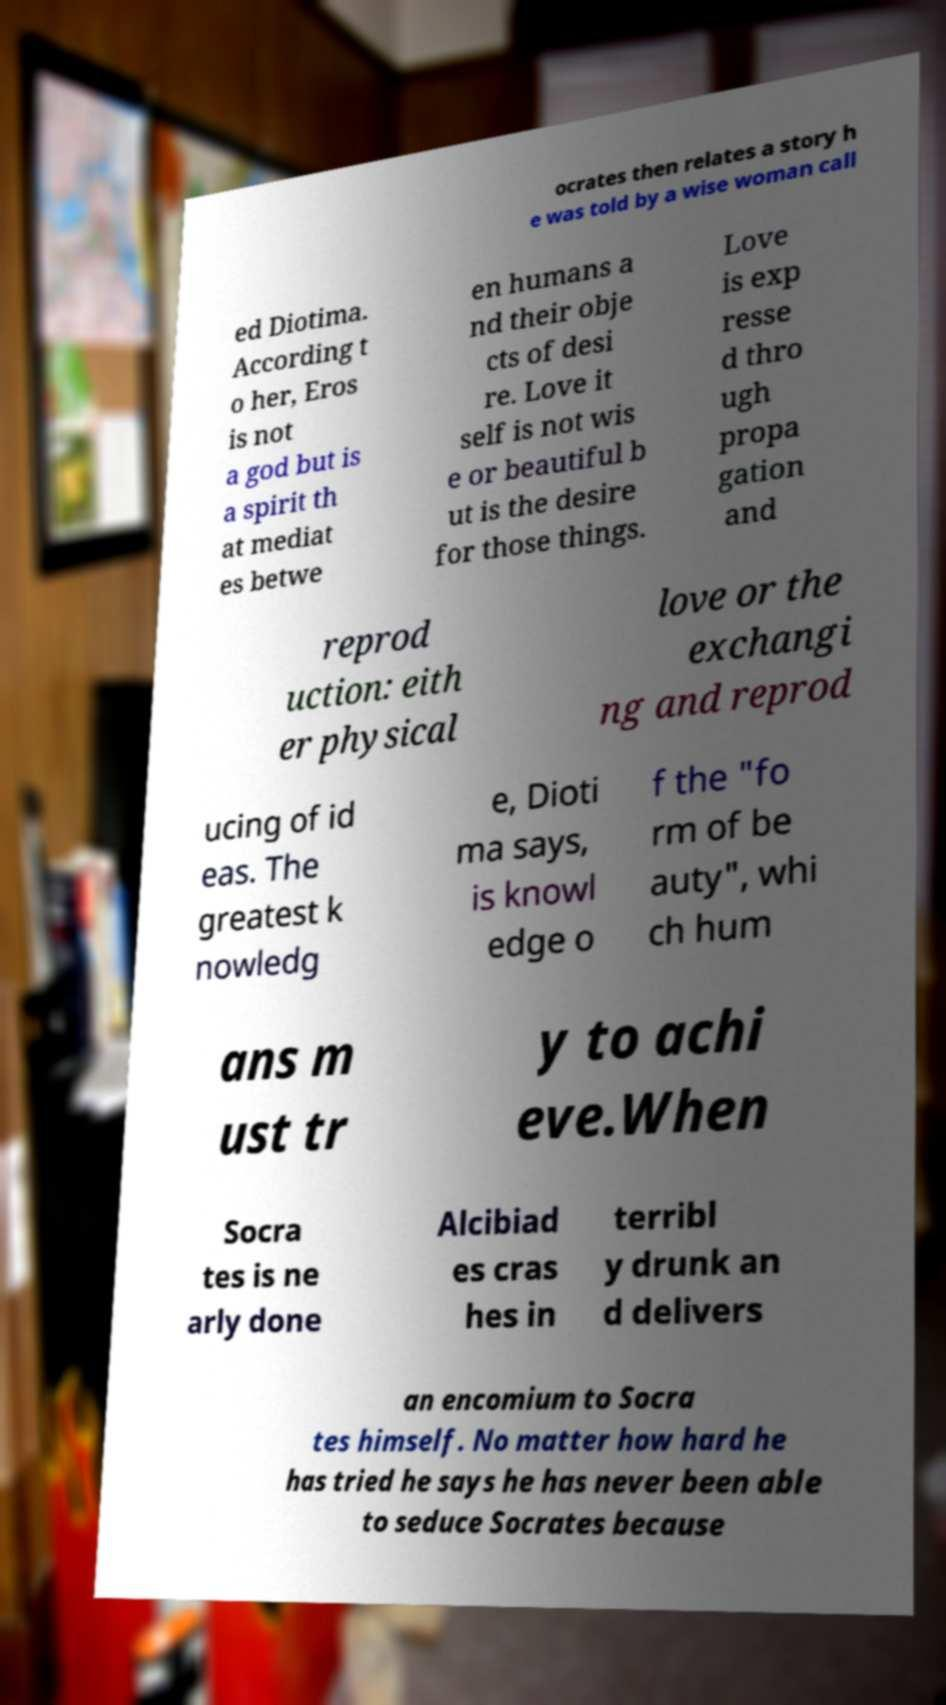Please read and relay the text visible in this image. What does it say? ocrates then relates a story h e was told by a wise woman call ed Diotima. According t o her, Eros is not a god but is a spirit th at mediat es betwe en humans a nd their obje cts of desi re. Love it self is not wis e or beautiful b ut is the desire for those things. Love is exp resse d thro ugh propa gation and reprod uction: eith er physical love or the exchangi ng and reprod ucing of id eas. The greatest k nowledg e, Dioti ma says, is knowl edge o f the "fo rm of be auty", whi ch hum ans m ust tr y to achi eve.When Socra tes is ne arly done Alcibiad es cras hes in terribl y drunk an d delivers an encomium to Socra tes himself. No matter how hard he has tried he says he has never been able to seduce Socrates because 